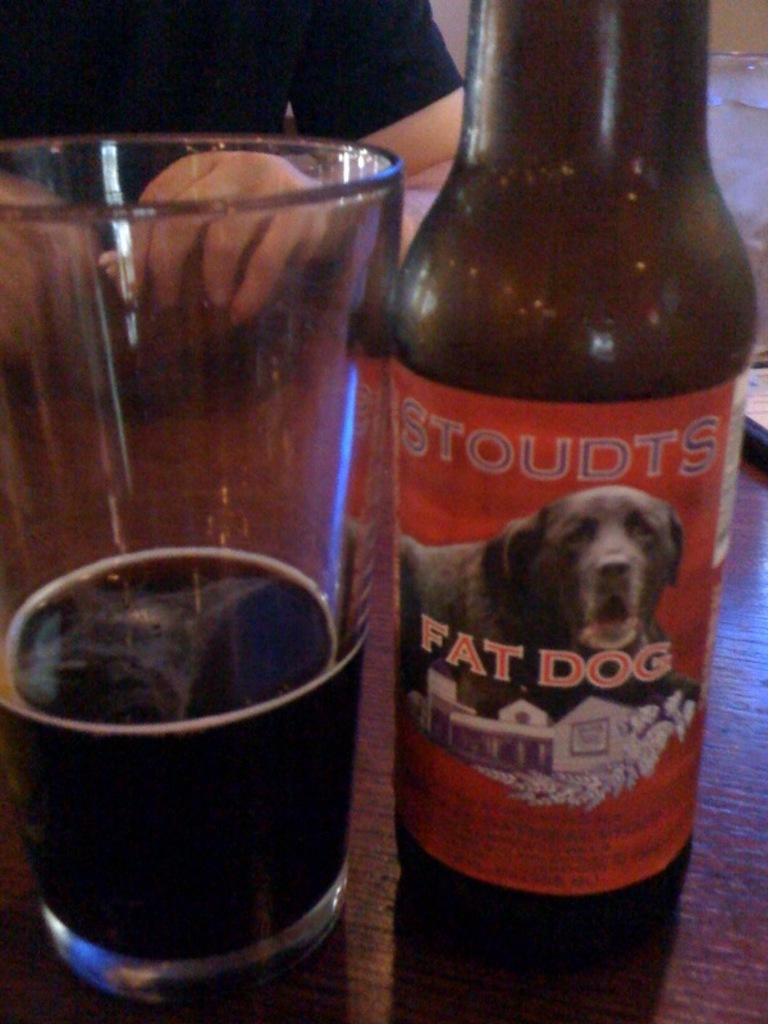What is located in the foreground of the image? There is an alcohol bottle and a glass of wine in the foreground of the image. What is the surface on which the objects are placed? The objects are on a wooden table. Can you describe the background of the image? There is a person in the background of the image, but their face is not visible. What type of sweater is the person wearing in the image? There is no person wearing a sweater in the image, as the person's face is not visible and their clothing is not described. 